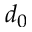Convert formula to latex. <formula><loc_0><loc_0><loc_500><loc_500>d _ { 0 }</formula> 